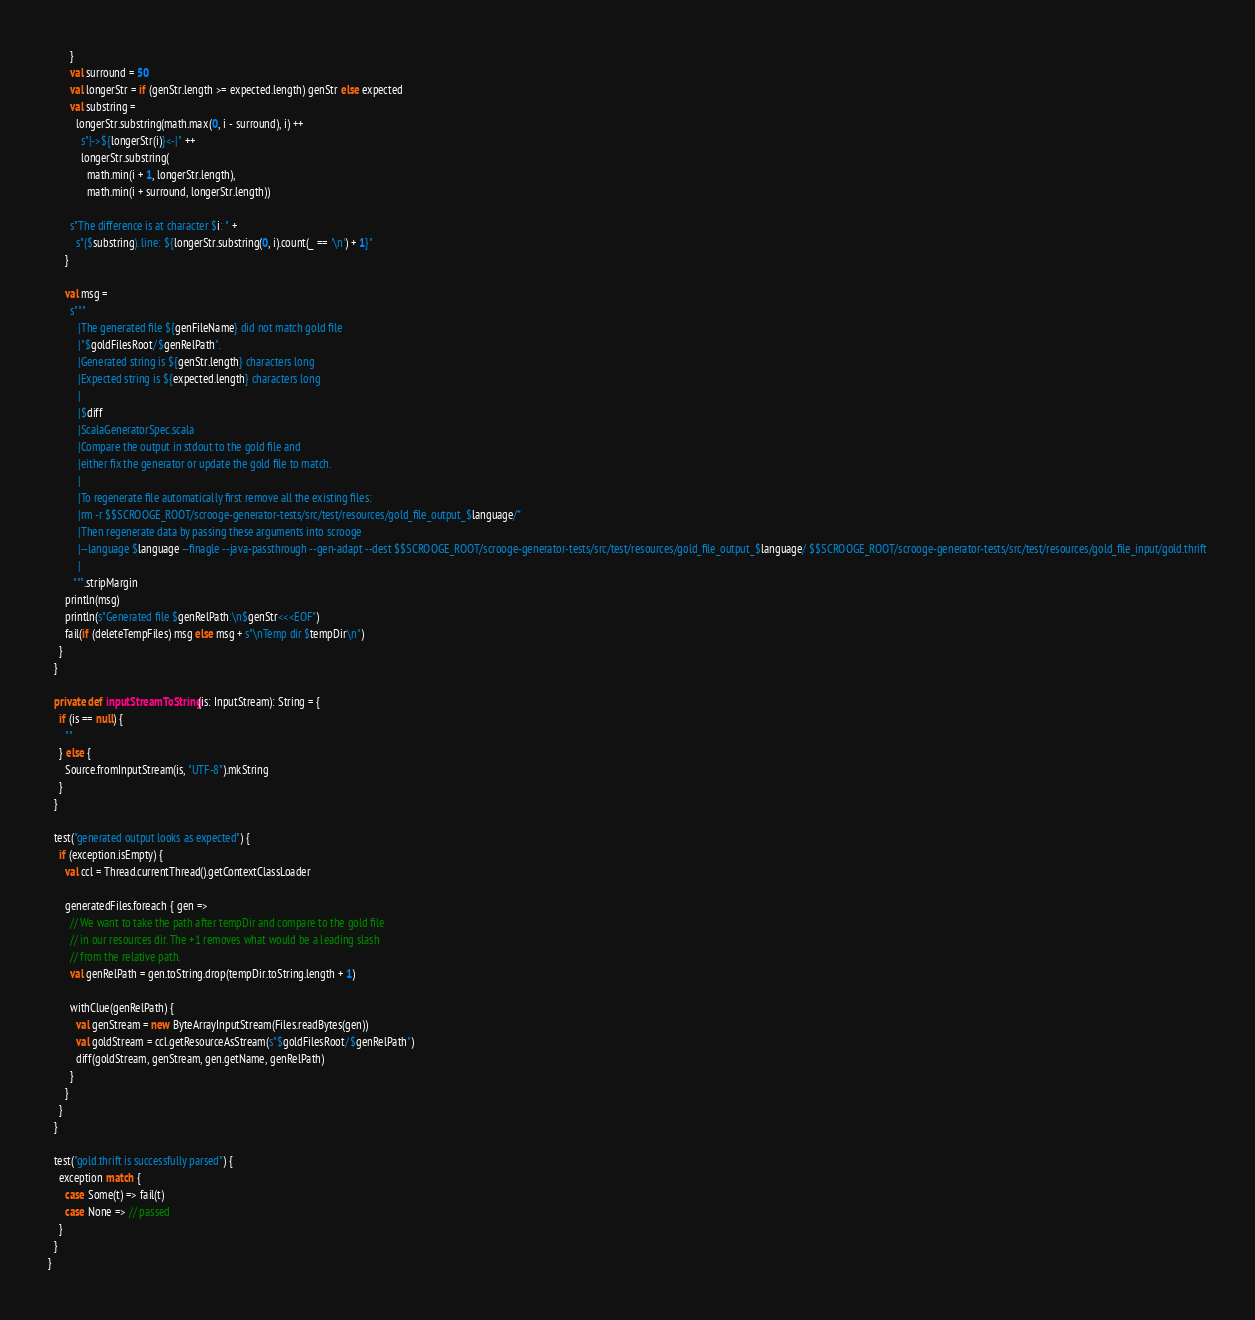<code> <loc_0><loc_0><loc_500><loc_500><_Scala_>        }
        val surround = 50
        val longerStr = if (genStr.length >= expected.length) genStr else expected
        val substring =
          longerStr.substring(math.max(0, i - surround), i) ++
            s"|->${longerStr(i)}<-|" ++
            longerStr.substring(
              math.min(i + 1, longerStr.length),
              math.min(i + surround, longerStr.length))

        s"The difference is at character $i: " +
          s"($substring). line: ${longerStr.substring(0, i).count(_ == '\n') + 1}"
      }

      val msg =
        s"""
           |The generated file ${genFileName} did not match gold file
           |"$goldFilesRoot/$genRelPath".
           |Generated string is ${genStr.length} characters long
           |Expected string is ${expected.length} characters long
           |
           |$diff
           |ScalaGeneratorSpec.scala
           |Compare the output in stdout to the gold file and
           |either fix the generator or update the gold file to match.
           |
           |To regenerate file automatically first remove all the existing files:
           |rm -r $$SCROOGE_ROOT/scrooge-generator-tests/src/test/resources/gold_file_output_$language/*
           |Then regenerate data by passing these arguments into scrooge
           |--language $language --finagle --java-passthrough --gen-adapt --dest $$SCROOGE_ROOT/scrooge-generator-tests/src/test/resources/gold_file_output_$language/ $$SCROOGE_ROOT/scrooge-generator-tests/src/test/resources/gold_file_input/gold.thrift
           |
         """.stripMargin
      println(msg)
      println(s"Generated file $genRelPath:\n$genStr<<<EOF")
      fail(if (deleteTempFiles) msg else msg + s"\nTemp dir $tempDir\n")
    }
  }

  private def inputStreamToString(is: InputStream): String = {
    if (is == null) {
      ""
    } else {
      Source.fromInputStream(is, "UTF-8").mkString
    }
  }

  test("generated output looks as expected") {
    if (exception.isEmpty) {
      val ccl = Thread.currentThread().getContextClassLoader

      generatedFiles.foreach { gen =>
        // We want to take the path after tempDir and compare to the gold file
        // in our resources dir. The +1 removes what would be a leading slash
        // from the relative path.
        val genRelPath = gen.toString.drop(tempDir.toString.length + 1)

        withClue(genRelPath) {
          val genStream = new ByteArrayInputStream(Files.readBytes(gen))
          val goldStream = ccl.getResourceAsStream(s"$goldFilesRoot/$genRelPath")
          diff(goldStream, genStream, gen.getName, genRelPath)
        }
      }
    }
  }

  test("gold.thrift is successfully parsed") {
    exception match {
      case Some(t) => fail(t)
      case None => // passed
    }
  }
}
</code> 